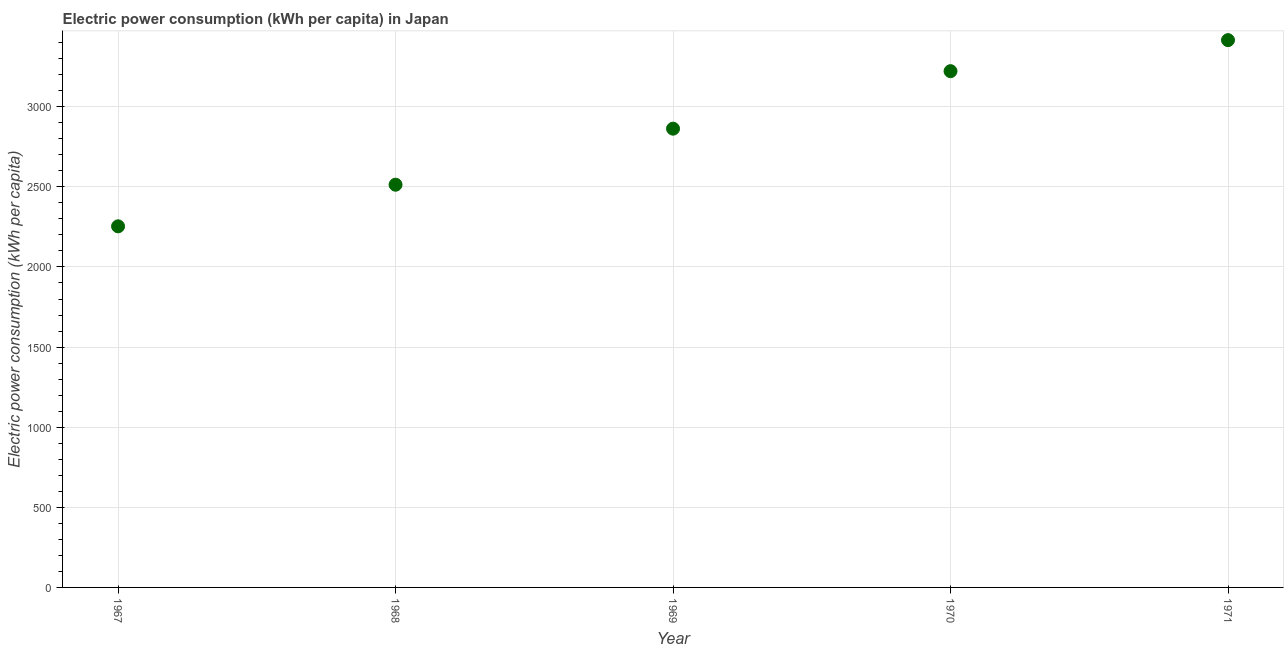What is the electric power consumption in 1969?
Keep it short and to the point. 2863.18. Across all years, what is the maximum electric power consumption?
Provide a succinct answer. 3415.69. Across all years, what is the minimum electric power consumption?
Your response must be concise. 2253.66. In which year was the electric power consumption maximum?
Make the answer very short. 1971. In which year was the electric power consumption minimum?
Your answer should be compact. 1967. What is the sum of the electric power consumption?
Your answer should be compact. 1.43e+04. What is the difference between the electric power consumption in 1968 and 1970?
Provide a short and direct response. -708.67. What is the average electric power consumption per year?
Your answer should be compact. 2853.57. What is the median electric power consumption?
Ensure brevity in your answer.  2863.18. In how many years, is the electric power consumption greater than 2400 kWh per capita?
Provide a short and direct response. 4. Do a majority of the years between 1967 and 1968 (inclusive) have electric power consumption greater than 2000 kWh per capita?
Provide a short and direct response. Yes. What is the ratio of the electric power consumption in 1968 to that in 1969?
Ensure brevity in your answer.  0.88. Is the electric power consumption in 1968 less than that in 1971?
Offer a terse response. Yes. What is the difference between the highest and the second highest electric power consumption?
Offer a terse response. 193.68. Is the sum of the electric power consumption in 1969 and 1970 greater than the maximum electric power consumption across all years?
Ensure brevity in your answer.  Yes. What is the difference between the highest and the lowest electric power consumption?
Your answer should be compact. 1162.03. In how many years, is the electric power consumption greater than the average electric power consumption taken over all years?
Provide a succinct answer. 3. How many years are there in the graph?
Make the answer very short. 5. What is the difference between two consecutive major ticks on the Y-axis?
Your answer should be very brief. 500. Does the graph contain any zero values?
Keep it short and to the point. No. What is the title of the graph?
Ensure brevity in your answer.  Electric power consumption (kWh per capita) in Japan. What is the label or title of the Y-axis?
Your answer should be very brief. Electric power consumption (kWh per capita). What is the Electric power consumption (kWh per capita) in 1967?
Provide a short and direct response. 2253.66. What is the Electric power consumption (kWh per capita) in 1968?
Provide a short and direct response. 2513.33. What is the Electric power consumption (kWh per capita) in 1969?
Offer a terse response. 2863.18. What is the Electric power consumption (kWh per capita) in 1970?
Give a very brief answer. 3222. What is the Electric power consumption (kWh per capita) in 1971?
Your response must be concise. 3415.69. What is the difference between the Electric power consumption (kWh per capita) in 1967 and 1968?
Give a very brief answer. -259.67. What is the difference between the Electric power consumption (kWh per capita) in 1967 and 1969?
Your answer should be compact. -609.52. What is the difference between the Electric power consumption (kWh per capita) in 1967 and 1970?
Provide a succinct answer. -968.34. What is the difference between the Electric power consumption (kWh per capita) in 1967 and 1971?
Your answer should be very brief. -1162.03. What is the difference between the Electric power consumption (kWh per capita) in 1968 and 1969?
Provide a short and direct response. -349.85. What is the difference between the Electric power consumption (kWh per capita) in 1968 and 1970?
Provide a succinct answer. -708.67. What is the difference between the Electric power consumption (kWh per capita) in 1968 and 1971?
Provide a succinct answer. -902.35. What is the difference between the Electric power consumption (kWh per capita) in 1969 and 1970?
Keep it short and to the point. -358.82. What is the difference between the Electric power consumption (kWh per capita) in 1969 and 1971?
Provide a succinct answer. -552.51. What is the difference between the Electric power consumption (kWh per capita) in 1970 and 1971?
Offer a very short reply. -193.68. What is the ratio of the Electric power consumption (kWh per capita) in 1967 to that in 1968?
Provide a succinct answer. 0.9. What is the ratio of the Electric power consumption (kWh per capita) in 1967 to that in 1969?
Offer a terse response. 0.79. What is the ratio of the Electric power consumption (kWh per capita) in 1967 to that in 1970?
Provide a succinct answer. 0.7. What is the ratio of the Electric power consumption (kWh per capita) in 1967 to that in 1971?
Your response must be concise. 0.66. What is the ratio of the Electric power consumption (kWh per capita) in 1968 to that in 1969?
Provide a short and direct response. 0.88. What is the ratio of the Electric power consumption (kWh per capita) in 1968 to that in 1970?
Your answer should be compact. 0.78. What is the ratio of the Electric power consumption (kWh per capita) in 1968 to that in 1971?
Your answer should be compact. 0.74. What is the ratio of the Electric power consumption (kWh per capita) in 1969 to that in 1970?
Keep it short and to the point. 0.89. What is the ratio of the Electric power consumption (kWh per capita) in 1969 to that in 1971?
Offer a terse response. 0.84. What is the ratio of the Electric power consumption (kWh per capita) in 1970 to that in 1971?
Offer a terse response. 0.94. 